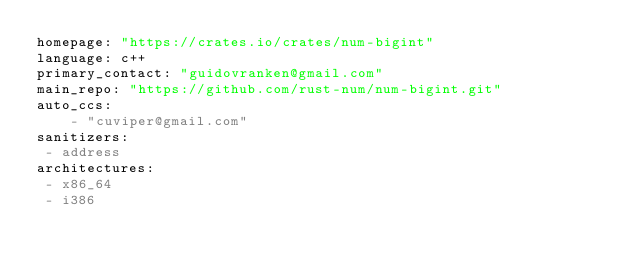Convert code to text. <code><loc_0><loc_0><loc_500><loc_500><_YAML_>homepage: "https://crates.io/crates/num-bigint"
language: c++
primary_contact: "guidovranken@gmail.com"
main_repo: "https://github.com/rust-num/num-bigint.git"
auto_ccs:
    - "cuviper@gmail.com"
sanitizers:
 - address
architectures:
 - x86_64
 - i386
</code> 